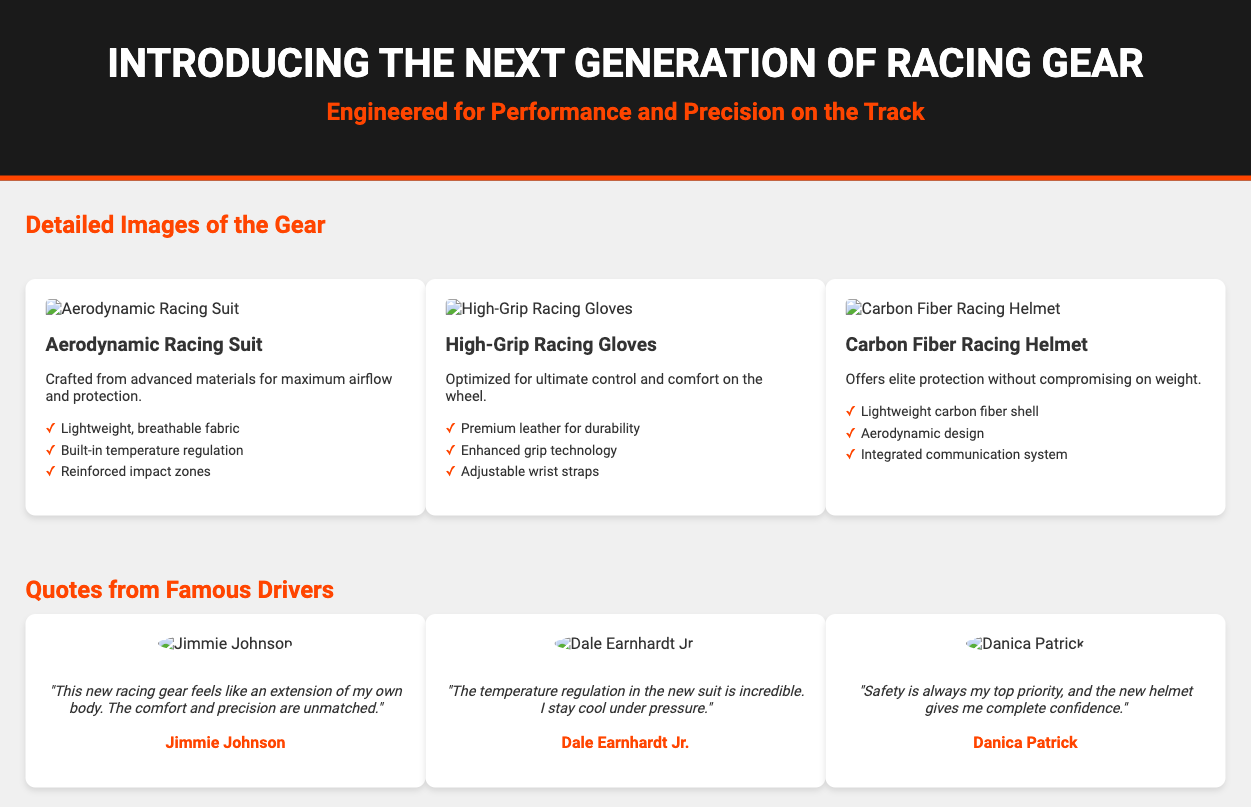What is the title of the product packaging? The title of the product packaging is prominently displayed in the header section of the document.
Answer: Introducing the Next Generation of Racing Gear What is the first product listed in the document? The first product is the one displayed in the first product card under the detailed images of the gear.
Answer: Aerodynamic Racing Suit How many features are listed for the High-Grip Racing Gloves? The features list is available in the product card for the High-Grip Racing Gloves.
Answer: Three What color is used for the header background? The header background color is specified in the styling section.
Answer: Black Which famous driver commented on the new racing gear's comfort? The quote section provides insights from famous drivers regarding their experiences with the gear.
Answer: Jimmie Johnson What is the advantage of the Carbon Fiber Racing Helmet mentioned? The advantages are detailed in the description section of the product card.
Answer: Elite protection How many testimonials are presented in the document? The testimonials section contains insights from famous drivers displayed in individual cards.
Answer: Three What feature enhances the grip of the High-Grip Racing Gloves? The features listed for the High-Grip Racing Gloves include enhancements focused on grip technology.
Answer: Enhanced grip technology What is the primary focus of the promotional box? The document conveys information focused on the type of gear and its unique selling points.
Answer: Performance and Precision 